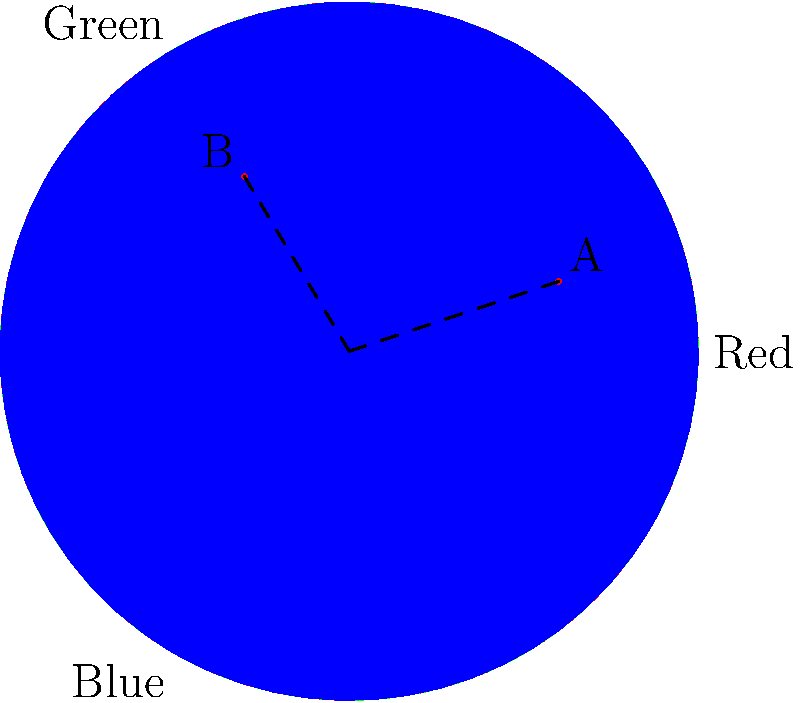As a fresco artist, you're recreating an ancient color palette. The color wheel above represents the primary colors used in historical pigments. Point A represents a desired ochre color, while point B represents a desired sage green. Given that the distance from the center to any primary color on the wheel is 1 unit, calculate the ratio of red to green pigments needed to create the sage green color (point B). To solve this problem, we need to follow these steps:

1) First, we need to determine the coordinates of point B. From the diagram, we can estimate that B is at approximately (-0.3, 0.5).

2) In the RGB color model, the coordinates of a point in the color wheel represent the relative amounts of each primary color. The x-coordinate represents the difference between red and green, while the y-coordinate represents the amount of blue.

3) For point B:
   x = -0.3 (negative means more green than red)
   y = 0.5 (amount of blue)

4) To find the amount of red and green, we need to solve:
   R - G = -0.3
   R + G = 1 - 0.5 = 0.5 (because the total of all colors must be 1, and we know the amount of blue is 0.5)

5) Solving this system of equations:
   R - G = -0.3
   R + G = 0.5
   
   Adding these equations:
   2R = 0.2
   R = 0.1

   Substituting back:
   0.1 - G = -0.3
   G = 0.4

6) Therefore, the ratio of red to green is 0.1 : 0.4, which simplifies to 1 : 4.
Answer: 1:4 